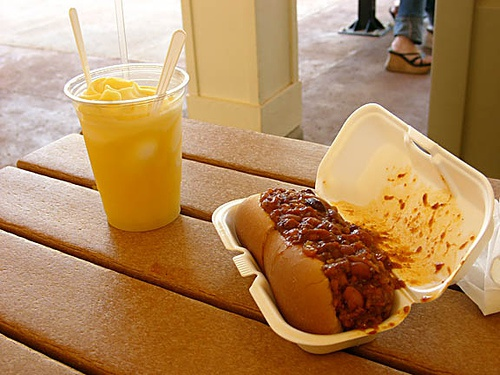Describe the objects in this image and their specific colors. I can see dining table in white, brown, maroon, and tan tones, hot dog in white, maroon, and brown tones, cup in white, orange, and ivory tones, people in white, black, gray, and maroon tones, and spoon in white, tan, and ivory tones in this image. 